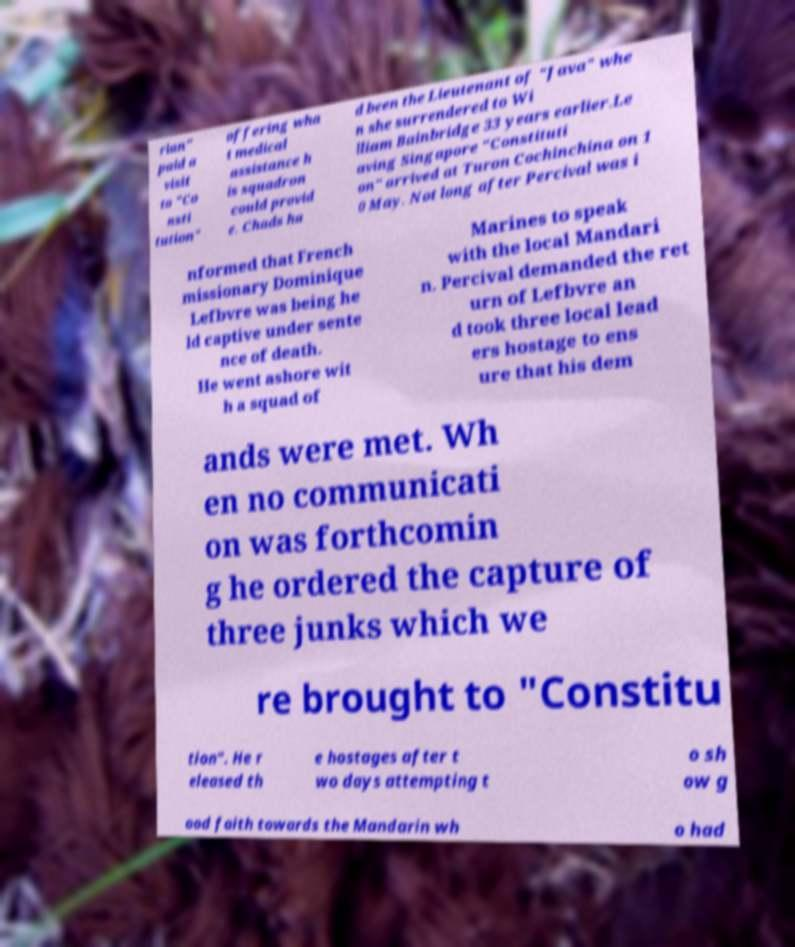I need the written content from this picture converted into text. Can you do that? rian" paid a visit to "Co nsti tution" offering wha t medical assistance h is squadron could provid e. Chads ha d been the Lieutenant of "Java" whe n she surrendered to Wi lliam Bainbridge 33 years earlier.Le aving Singapore "Constituti on" arrived at Turon Cochinchina on 1 0 May. Not long after Percival was i nformed that French missionary Dominique Lefbvre was being he ld captive under sente nce of death. He went ashore wit h a squad of Marines to speak with the local Mandari n. Percival demanded the ret urn of Lefbvre an d took three local lead ers hostage to ens ure that his dem ands were met. Wh en no communicati on was forthcomin g he ordered the capture of three junks which we re brought to "Constitu tion". He r eleased th e hostages after t wo days attempting t o sh ow g ood faith towards the Mandarin wh o had 